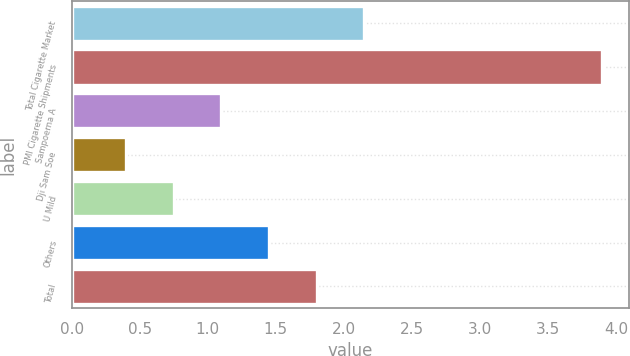<chart> <loc_0><loc_0><loc_500><loc_500><bar_chart><fcel>Total Cigarette Market<fcel>PMI Cigarette Shipments<fcel>Sampoerna A<fcel>Dji Sam Soe<fcel>U Mild<fcel>Others<fcel>Total<nl><fcel>2.15<fcel>3.9<fcel>1.1<fcel>0.4<fcel>0.75<fcel>1.45<fcel>1.8<nl></chart> 